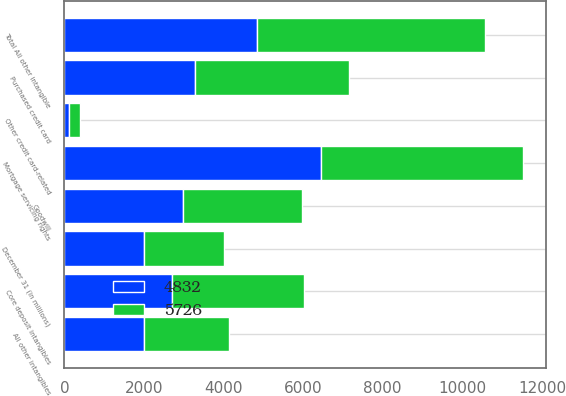Convert chart. <chart><loc_0><loc_0><loc_500><loc_500><stacked_bar_chart><ecel><fcel>December 31 (in millions)<fcel>Goodwill<fcel>Mortgage servicing rights<fcel>Purchased credit card<fcel>Other credit card-related<fcel>Core deposit intangibles<fcel>All other intangibles<fcel>Total All other intangible<nl><fcel>4832<fcel>2005<fcel>2990<fcel>6452<fcel>3275<fcel>124<fcel>2705<fcel>2003<fcel>4832<nl><fcel>5726<fcel>2004<fcel>2990<fcel>5080<fcel>3878<fcel>272<fcel>3328<fcel>2126<fcel>5726<nl></chart> 